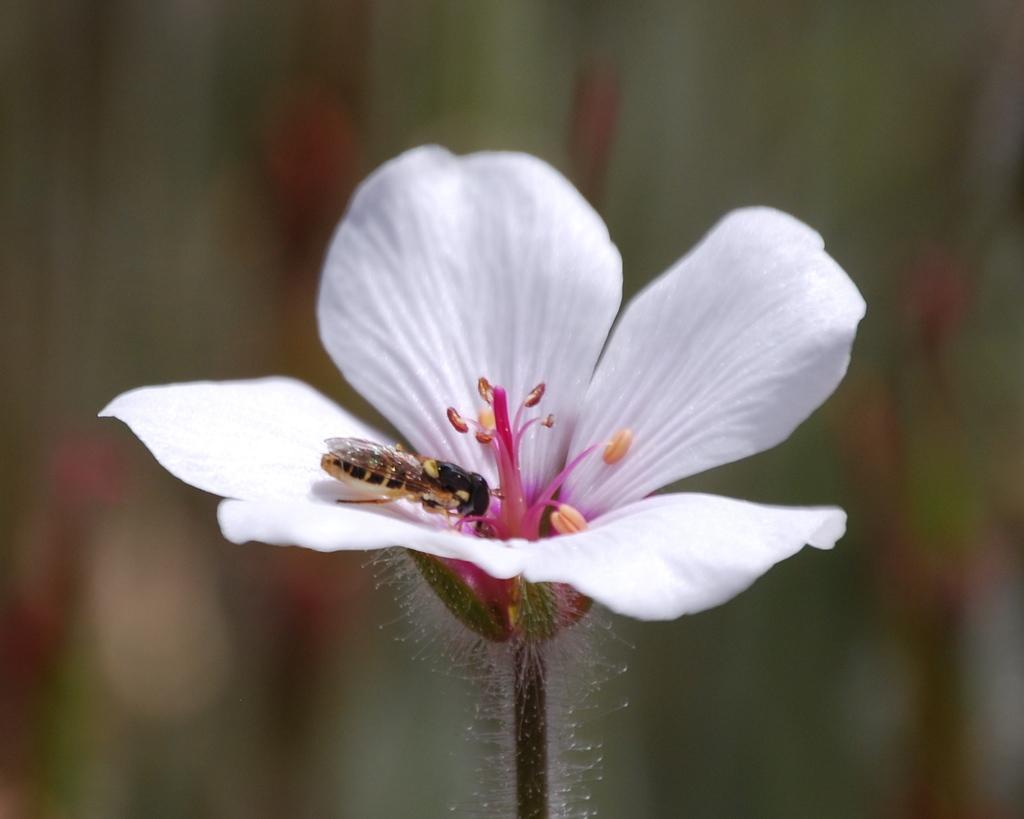In one or two sentences, can you explain what this image depicts? In this image we can see a flower. On the flower there is an insect. In the background it is blur. 